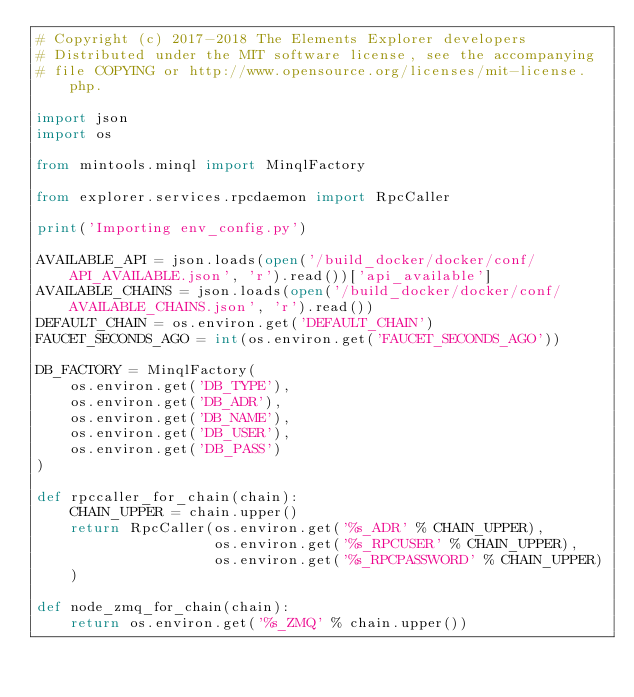Convert code to text. <code><loc_0><loc_0><loc_500><loc_500><_Python_># Copyright (c) 2017-2018 The Elements Explorer developers
# Distributed under the MIT software license, see the accompanying
# file COPYING or http://www.opensource.org/licenses/mit-license.php.

import json
import os

from mintools.minql import MinqlFactory

from explorer.services.rpcdaemon import RpcCaller

print('Importing env_config.py')

AVAILABLE_API = json.loads(open('/build_docker/docker/conf/API_AVAILABLE.json', 'r').read())['api_available']
AVAILABLE_CHAINS = json.loads(open('/build_docker/docker/conf/AVAILABLE_CHAINS.json', 'r').read())
DEFAULT_CHAIN = os.environ.get('DEFAULT_CHAIN')
FAUCET_SECONDS_AGO = int(os.environ.get('FAUCET_SECONDS_AGO'))

DB_FACTORY = MinqlFactory(
    os.environ.get('DB_TYPE'),
    os.environ.get('DB_ADR'),
    os.environ.get('DB_NAME'),
    os.environ.get('DB_USER'),
    os.environ.get('DB_PASS')
)

def rpccaller_for_chain(chain):
    CHAIN_UPPER = chain.upper()
    return RpcCaller(os.environ.get('%s_ADR' % CHAIN_UPPER),
                     os.environ.get('%s_RPCUSER' % CHAIN_UPPER),
                     os.environ.get('%s_RPCPASSWORD' % CHAIN_UPPER)
    )

def node_zmq_for_chain(chain):
    return os.environ.get('%s_ZMQ' % chain.upper())
</code> 